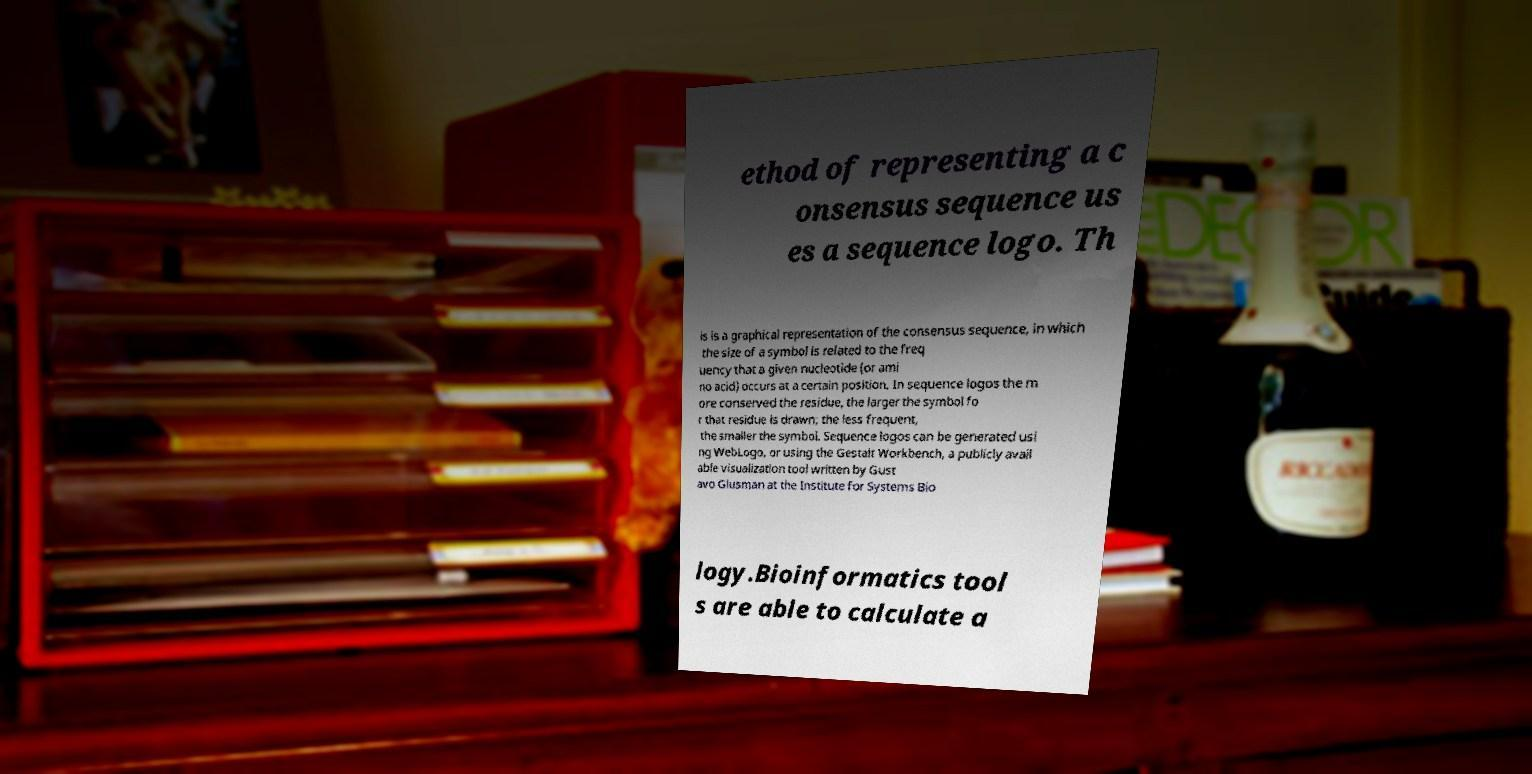Could you assist in decoding the text presented in this image and type it out clearly? ethod of representing a c onsensus sequence us es a sequence logo. Th is is a graphical representation of the consensus sequence, in which the size of a symbol is related to the freq uency that a given nucleotide (or ami no acid) occurs at a certain position. In sequence logos the m ore conserved the residue, the larger the symbol fo r that residue is drawn; the less frequent, the smaller the symbol. Sequence logos can be generated usi ng WebLogo, or using the Gestalt Workbench, a publicly avail able visualization tool written by Gust avo Glusman at the Institute for Systems Bio logy.Bioinformatics tool s are able to calculate a 